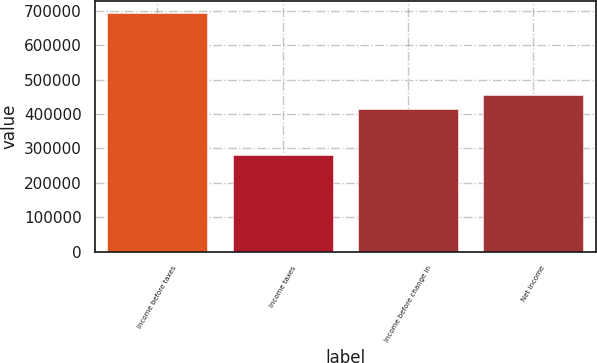<chart> <loc_0><loc_0><loc_500><loc_500><bar_chart><fcel>Income before taxes<fcel>Income taxes<fcel>Income before change in<fcel>Net income<nl><fcel>694869<fcel>280956<fcel>413913<fcel>455304<nl></chart> 